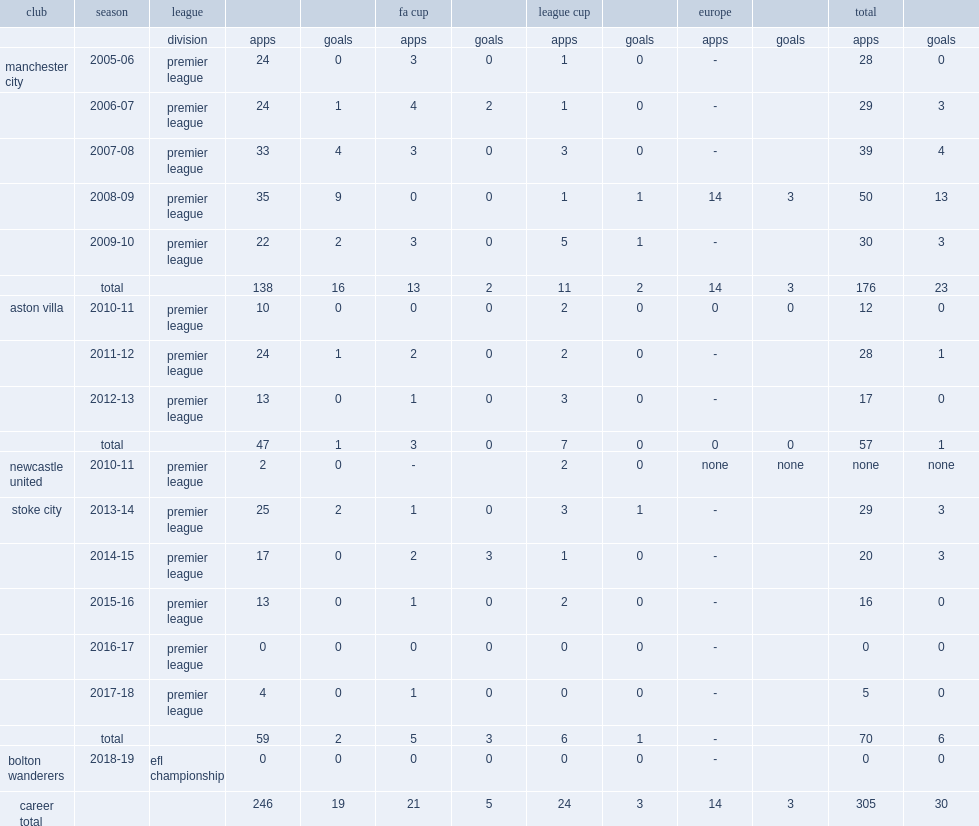Ireland moved from manchester city to aston villa, which league did he play in the 2010-11 season? Premier league. 